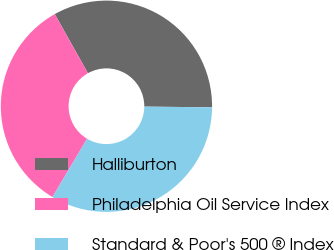<chart> <loc_0><loc_0><loc_500><loc_500><pie_chart><fcel>Halliburton<fcel>Philadelphia Oil Service Index<fcel>Standard & Poor's 500 ® Index<nl><fcel>33.3%<fcel>33.33%<fcel>33.37%<nl></chart> 